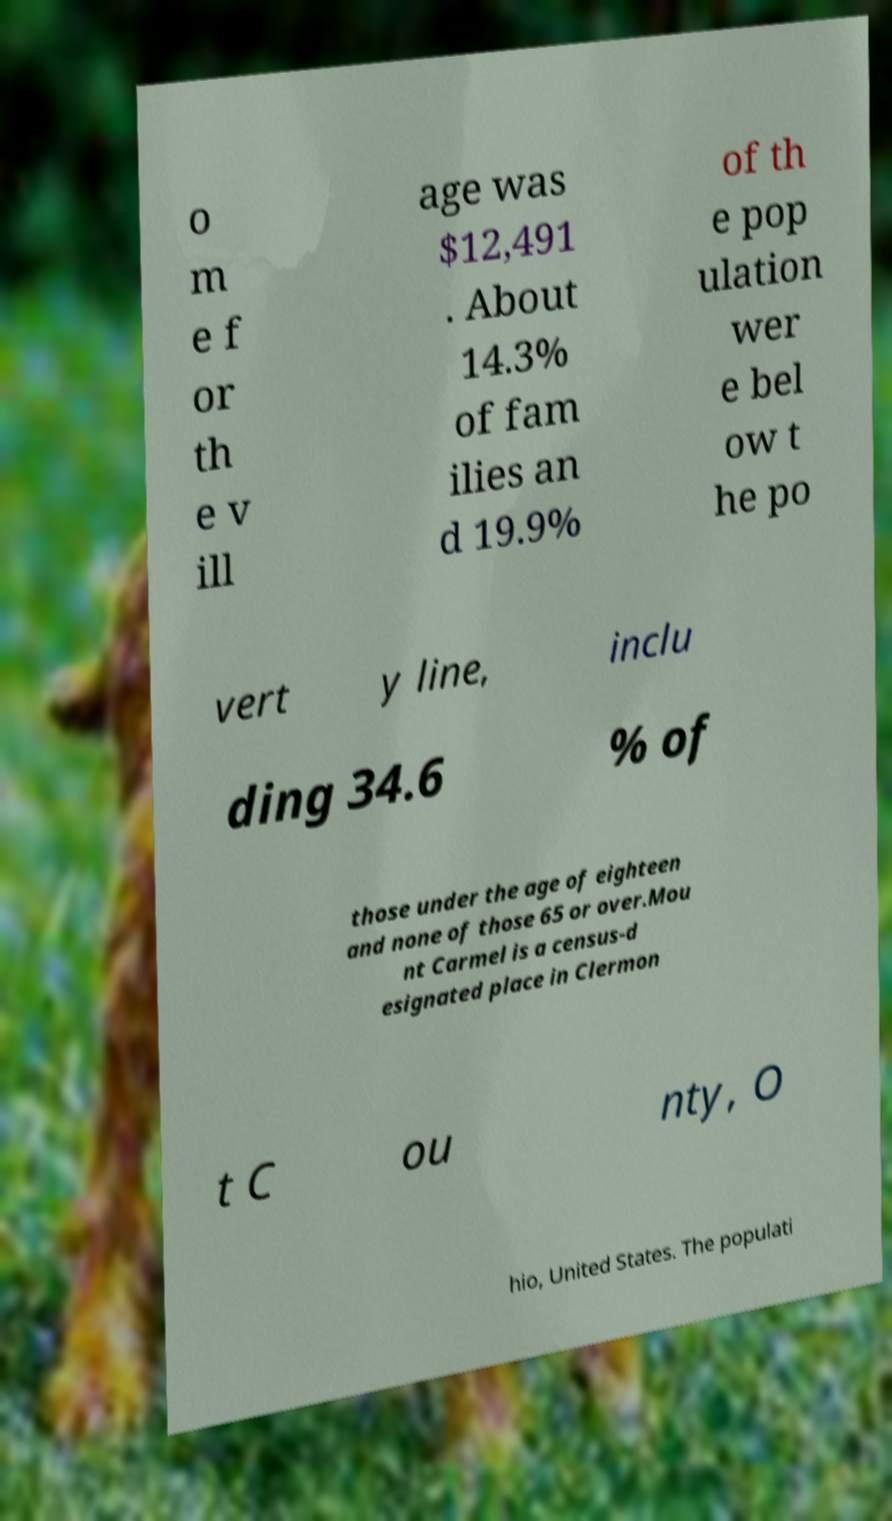What messages or text are displayed in this image? I need them in a readable, typed format. o m e f or th e v ill age was $12,491 . About 14.3% of fam ilies an d 19.9% of th e pop ulation wer e bel ow t he po vert y line, inclu ding 34.6 % of those under the age of eighteen and none of those 65 or over.Mou nt Carmel is a census-d esignated place in Clermon t C ou nty, O hio, United States. The populati 